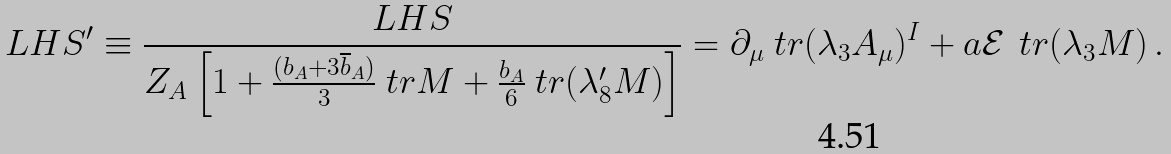<formula> <loc_0><loc_0><loc_500><loc_500>L H S ^ { \prime } \equiv \frac { L H S } { Z _ { A } \left [ 1 + \frac { ( b _ { A } + 3 \overline { b } _ { A } ) } { 3 } \ t r M + \frac { b _ { A } } { 6 } \ t r ( \lambda ^ { \prime } _ { 8 } M ) \right ] } = \partial _ { \mu } \ t r ( \lambda _ { 3 } A _ { \mu } ) ^ { I } + a \mathcal { E } \, \ t r ( \lambda _ { 3 } M ) \, .</formula> 